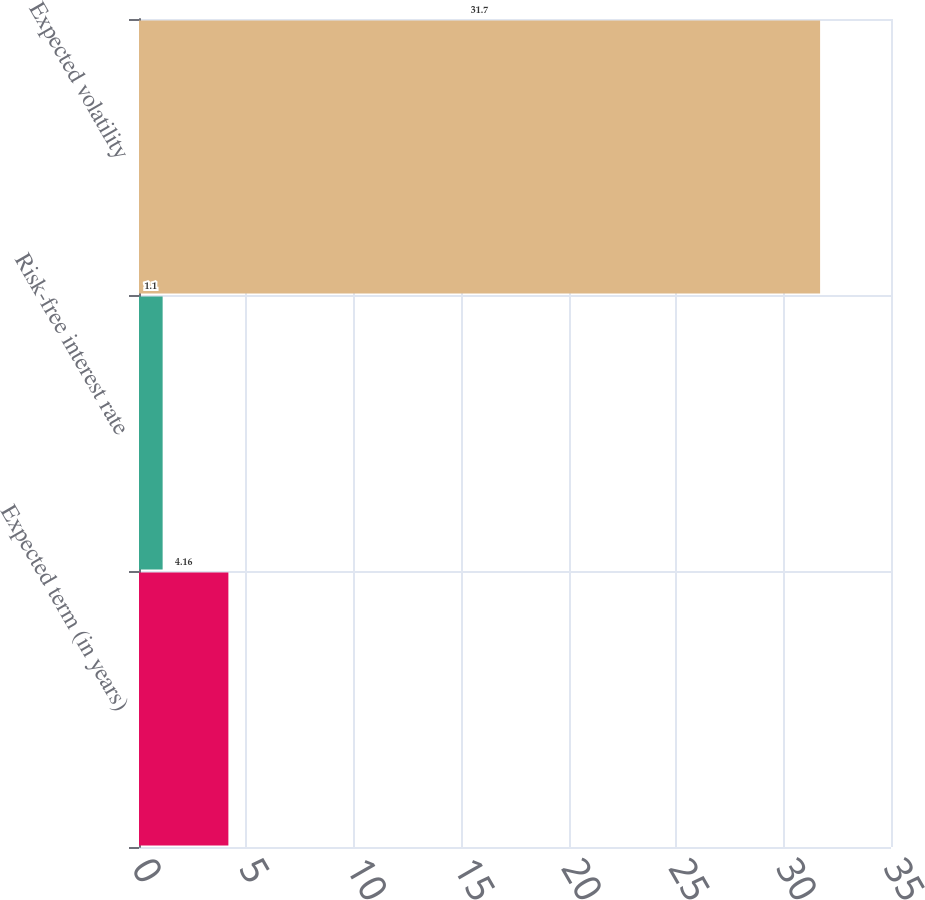Convert chart to OTSL. <chart><loc_0><loc_0><loc_500><loc_500><bar_chart><fcel>Expected term (in years)<fcel>Risk-free interest rate<fcel>Expected volatility<nl><fcel>4.16<fcel>1.1<fcel>31.7<nl></chart> 